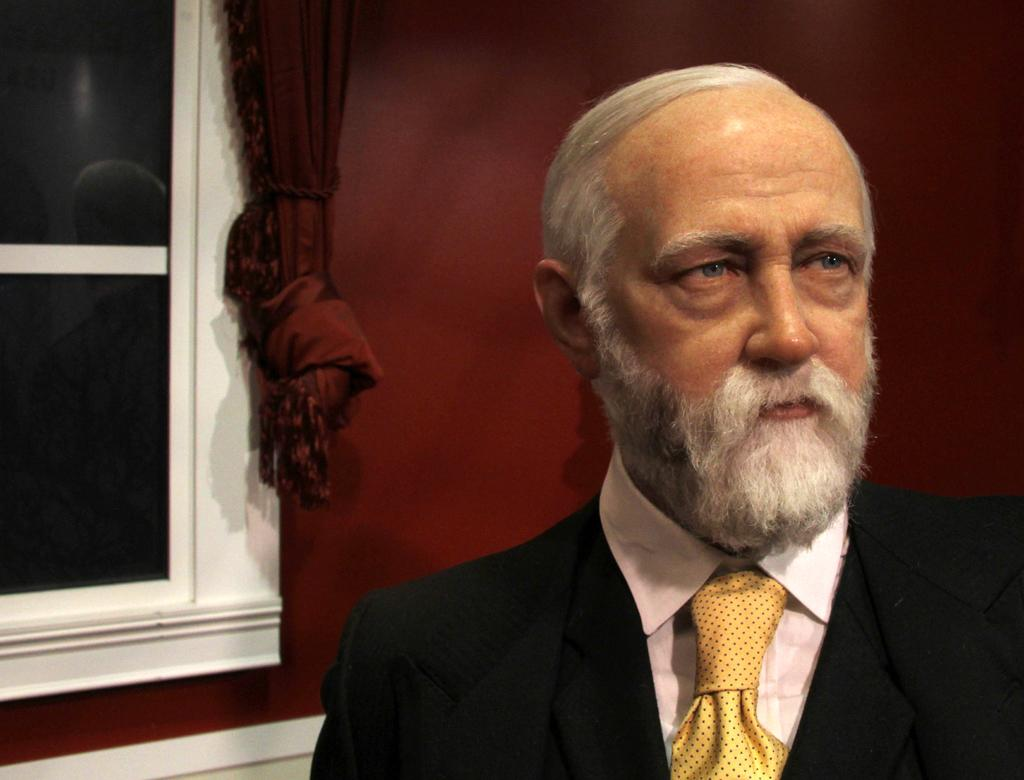Who is present in the image? There is a man in the image. What can be seen in the background of the image? There is a wall and a window in the background of the image. Is there any window treatment present in the image? Yes, there is a curtain associated with the window in the background of the image. What type of hat is the governor wearing in the image? There is no governor or hat present in the image; it only features a man and a background with a wall, window, and curtain. 